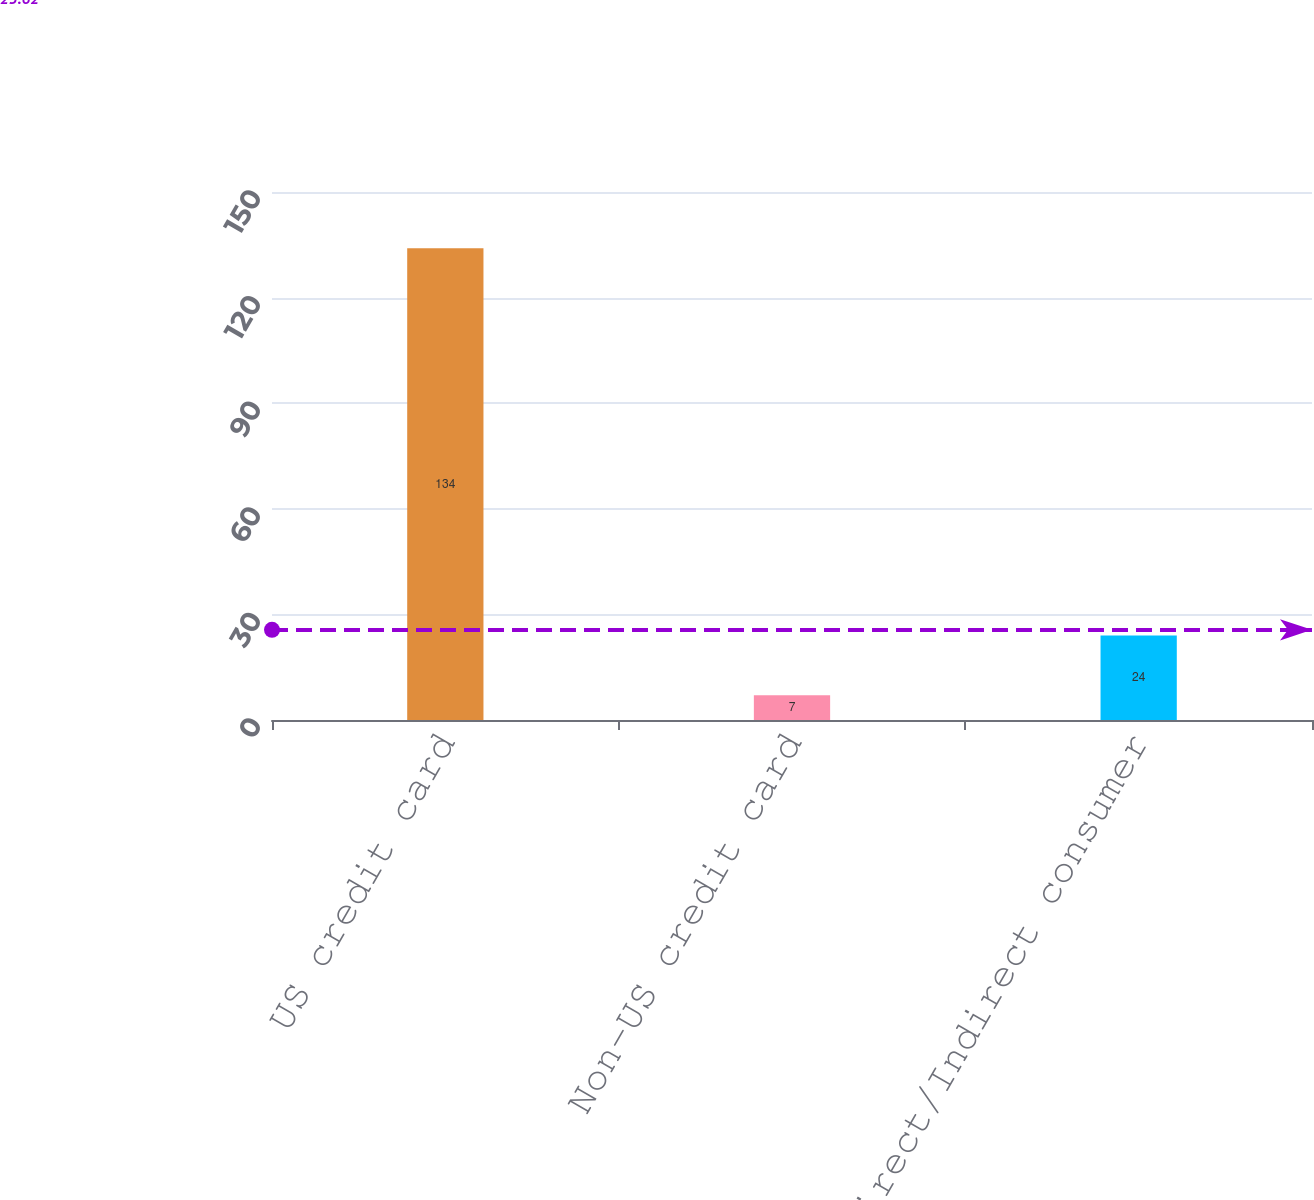Convert chart. <chart><loc_0><loc_0><loc_500><loc_500><bar_chart><fcel>US credit card<fcel>Non-US credit card<fcel>Direct/Indirect consumer<nl><fcel>134<fcel>7<fcel>24<nl></chart> 